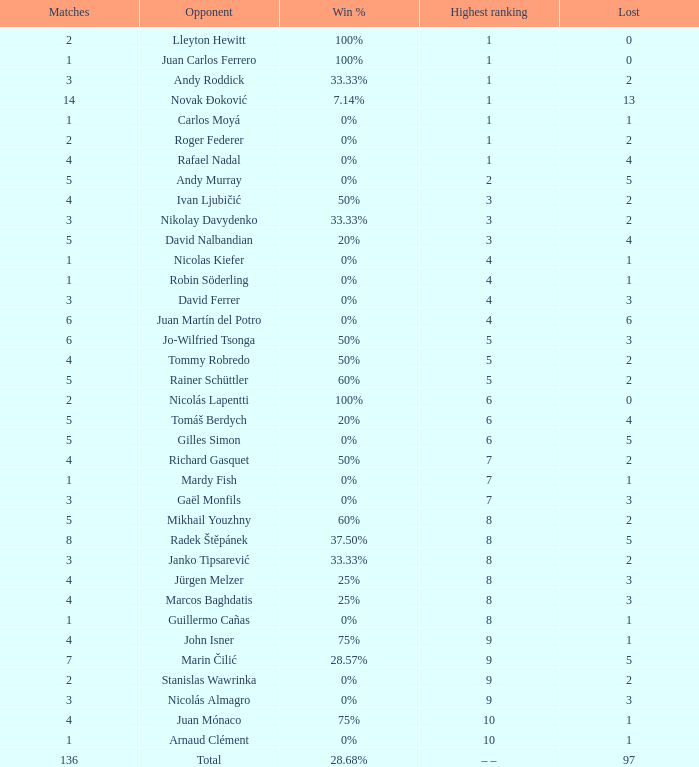What is the largest number Lost to david nalbandian with a Win Rate of 20%? 4.0. 